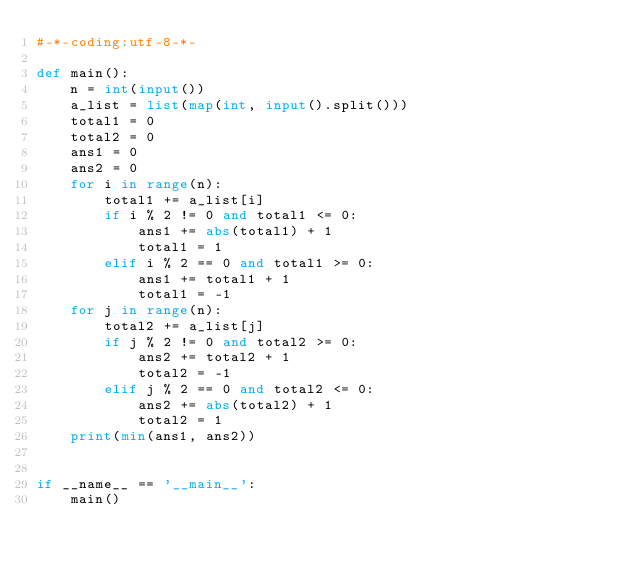<code> <loc_0><loc_0><loc_500><loc_500><_Python_>#-*-coding:utf-8-*-

def main():
    n = int(input())
    a_list = list(map(int, input().split()))
    total1 = 0
    total2 = 0
    ans1 = 0
    ans2 = 0
    for i in range(n):
        total1 += a_list[i]
        if i % 2 != 0 and total1 <= 0:
            ans1 += abs(total1) + 1
            total1 = 1
        elif i % 2 == 0 and total1 >= 0:
            ans1 += total1 + 1
            total1 = -1
    for j in range(n):
        total2 += a_list[j]
        if j % 2 != 0 and total2 >= 0:
            ans2 += total2 + 1
            total2 = -1
        elif j % 2 == 0 and total2 <= 0:
            ans2 += abs(total2) + 1
            total2 = 1
    print(min(ans1, ans2))
            

if __name__ == '__main__':
    main()</code> 